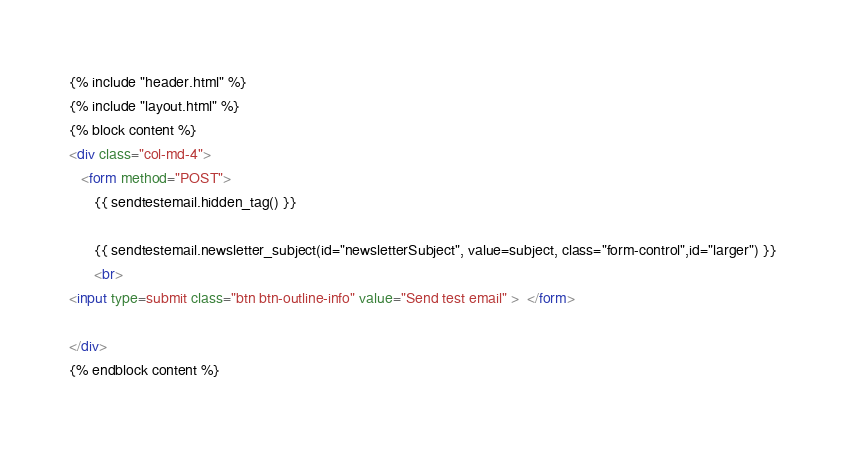Convert code to text. <code><loc_0><loc_0><loc_500><loc_500><_HTML_>{% include "header.html" %}
{% include "layout.html" %}
{% block content %}
<div class="col-md-4">
   <form method="POST">
      {{ sendtestemail.hidden_tag() }}

      {{ sendtestemail.newsletter_subject(id="newsletterSubject", value=subject, class="form-control",id="larger") }}
      <br>
<input type=submit class="btn btn-outline-info" value="Send test email" >  </form>

</div>
{% endblock content %}</code> 